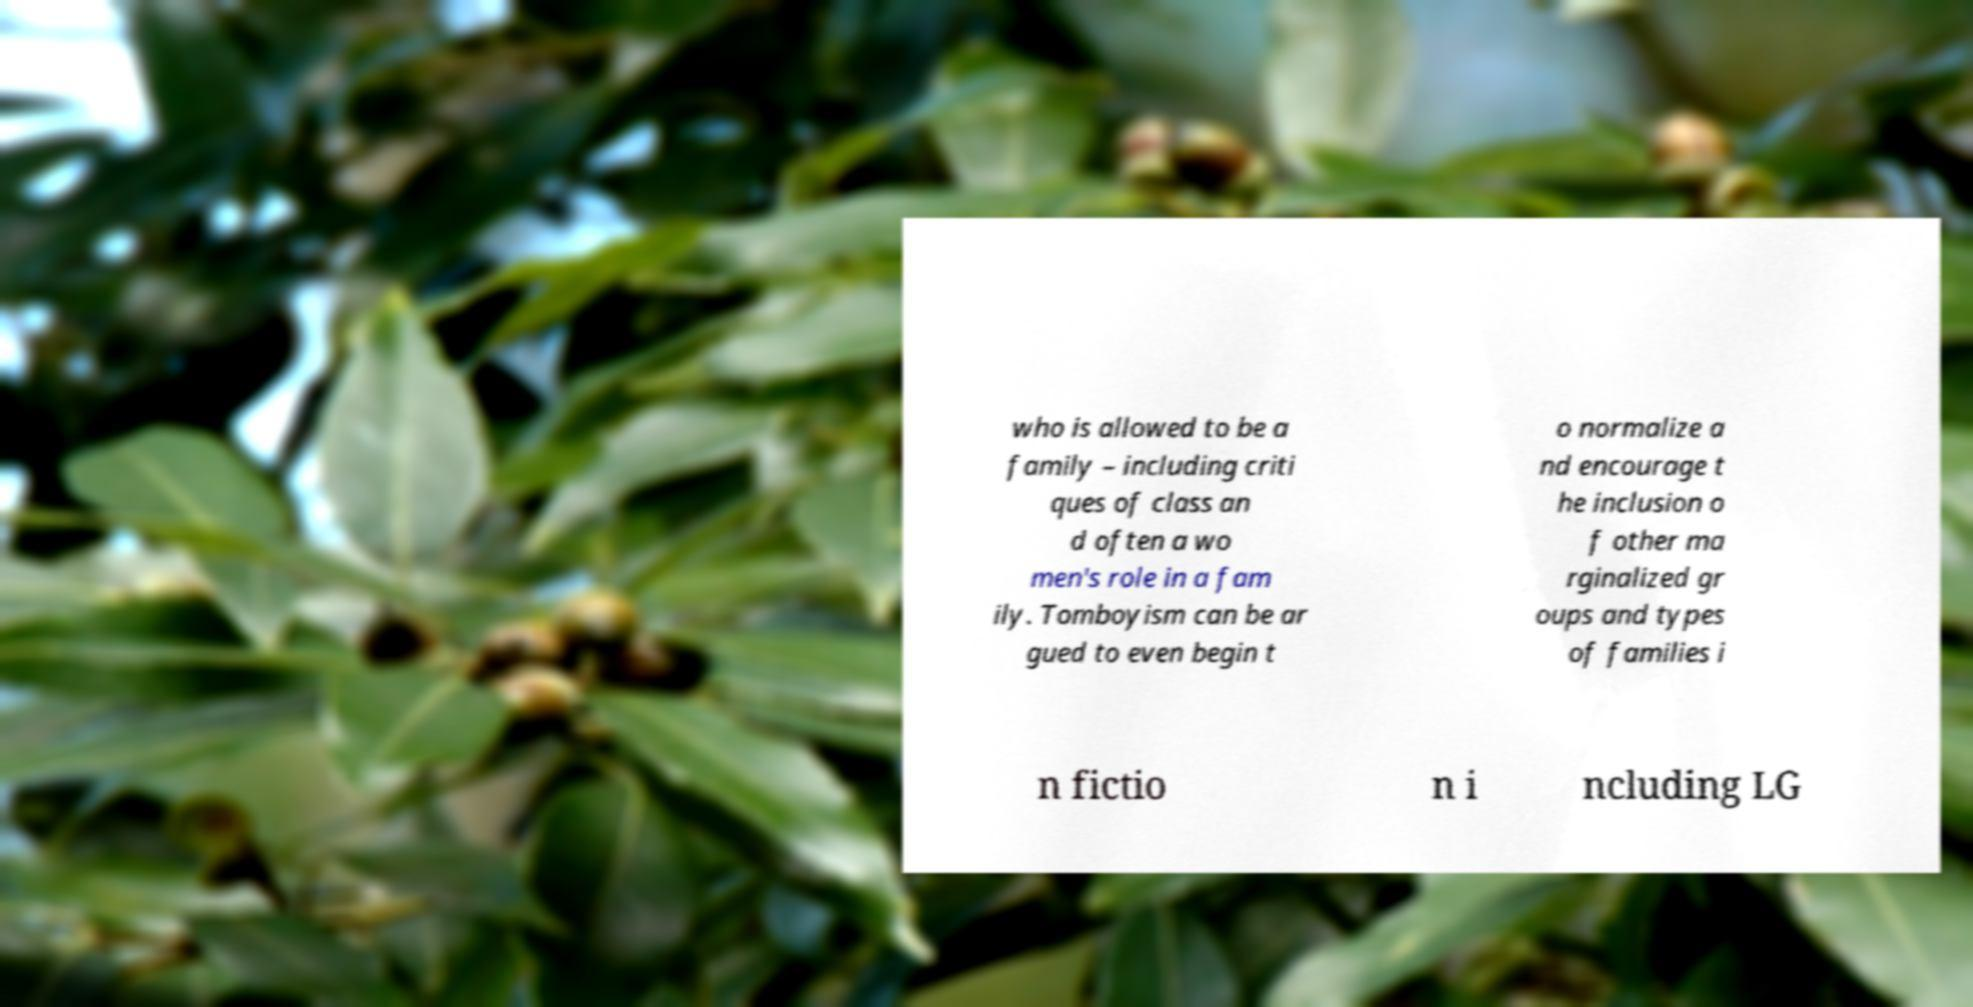Could you assist in decoding the text presented in this image and type it out clearly? who is allowed to be a family – including criti ques of class an d often a wo men's role in a fam ily. Tomboyism can be ar gued to even begin t o normalize a nd encourage t he inclusion o f other ma rginalized gr oups and types of families i n fictio n i ncluding LG 